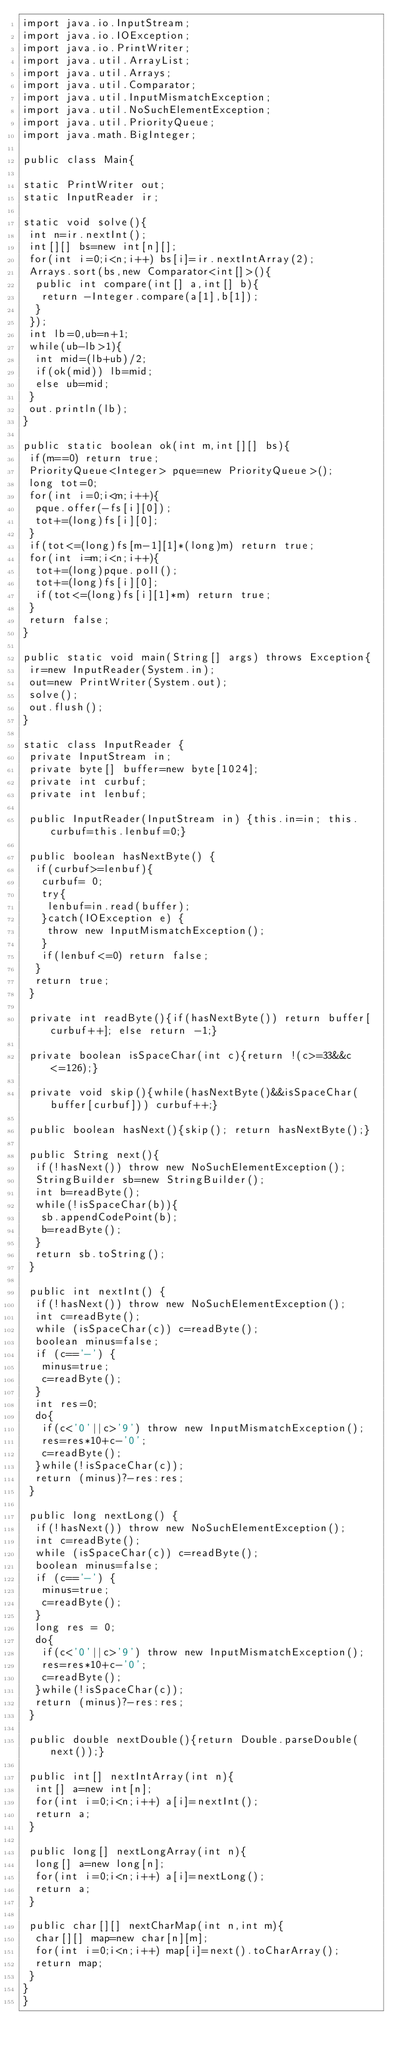<code> <loc_0><loc_0><loc_500><loc_500><_Java_>import java.io.InputStream;
import java.io.IOException;
import java.io.PrintWriter;
import java.util.ArrayList;
import java.util.Arrays;
import java.util.Comparator;
import java.util.InputMismatchException;
import java.util.NoSuchElementException;
import java.util.PriorityQueue;
import java.math.BigInteger;

public class Main{

static PrintWriter out;
static InputReader ir;

static void solve(){
 int n=ir.nextInt();
 int[][] bs=new int[n][];
 for(int i=0;i<n;i++) bs[i]=ir.nextIntArray(2);
 Arrays.sort(bs,new Comparator<int[]>(){
  public int compare(int[] a,int[] b){
   return -Integer.compare(a[1],b[1]);
  }
 });
 int lb=0,ub=n+1;
 while(ub-lb>1){
  int mid=(lb+ub)/2;
  if(ok(mid)) lb=mid;
  else ub=mid;
 }
 out.println(lb);
}

public static boolean ok(int m,int[][] bs){
 if(m==0) return true;
 PriorityQueue<Integer> pque=new PriorityQueue>();
 long tot=0;
 for(int i=0;i<m;i++){
  pque.offer(-fs[i][0]);
  tot+=(long)fs[i][0];
 }
 if(tot<=(long)fs[m-1][1]*(long)m) return true;
 for(int i=m;i<n;i++){
  tot+=(long)pque.poll();
  tot+=(long)fs[i][0];
  if(tot<=(long)fs[i][1]*m) return true;
 }
 return false;
}

public static void main(String[] args) throws Exception{
 ir=new InputReader(System.in);
 out=new PrintWriter(System.out);
 solve();
 out.flush();
}

static class InputReader {
 private InputStream in;
 private byte[] buffer=new byte[1024];
 private int curbuf;
 private int lenbuf;

 public InputReader(InputStream in) {this.in=in; this.curbuf=this.lenbuf=0;}
 
 public boolean hasNextByte() {
  if(curbuf>=lenbuf){
   curbuf= 0;
   try{
    lenbuf=in.read(buffer);
   }catch(IOException e) {
    throw new InputMismatchException();
   }
   if(lenbuf<=0) return false;
  }
  return true;
 }

 private int readByte(){if(hasNextByte()) return buffer[curbuf++]; else return -1;}
 
 private boolean isSpaceChar(int c){return !(c>=33&&c<=126);}
 
 private void skip(){while(hasNextByte()&&isSpaceChar(buffer[curbuf])) curbuf++;}
 
 public boolean hasNext(){skip(); return hasNextByte();}
 
 public String next(){
  if(!hasNext()) throw new NoSuchElementException();
  StringBuilder sb=new StringBuilder();
  int b=readByte();
  while(!isSpaceChar(b)){
   sb.appendCodePoint(b);
   b=readByte();
  }
  return sb.toString();
 }
 
 public int nextInt() {
  if(!hasNext()) throw new NoSuchElementException();
  int c=readByte();
  while (isSpaceChar(c)) c=readByte();
  boolean minus=false;
  if (c=='-') {
   minus=true;
   c=readByte();
  }
  int res=0;
  do{
   if(c<'0'||c>'9') throw new InputMismatchException();
   res=res*10+c-'0';
   c=readByte();
  }while(!isSpaceChar(c));
  return (minus)?-res:res;
 }
 
 public long nextLong() {
  if(!hasNext()) throw new NoSuchElementException();
  int c=readByte();
  while (isSpaceChar(c)) c=readByte();
  boolean minus=false;
  if (c=='-') {
   minus=true;
   c=readByte();
  }
  long res = 0;
  do{
   if(c<'0'||c>'9') throw new InputMismatchException();
   res=res*10+c-'0';
   c=readByte();
  }while(!isSpaceChar(c));
  return (minus)?-res:res;
 }

 public double nextDouble(){return Double.parseDouble(next());}

 public int[] nextIntArray(int n){
  int[] a=new int[n];
  for(int i=0;i<n;i++) a[i]=nextInt();
  return a;
 }

 public long[] nextLongArray(int n){
  long[] a=new long[n];
  for(int i=0;i<n;i++) a[i]=nextLong();
  return a;
 }

 public char[][] nextCharMap(int n,int m){
  char[][] map=new char[n][m];
  for(int i=0;i<n;i++) map[i]=next().toCharArray();
  return map;
 }
}
}</code> 